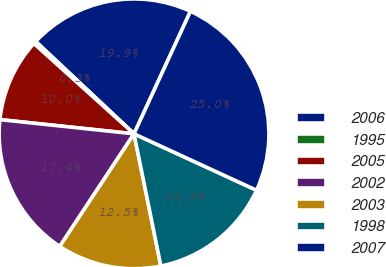Convert chart. <chart><loc_0><loc_0><loc_500><loc_500><pie_chart><fcel>2006<fcel>1995<fcel>2005<fcel>2002<fcel>2003<fcel>1998<fcel>2007<nl><fcel>19.87%<fcel>0.32%<fcel>10.0%<fcel>17.4%<fcel>12.47%<fcel>14.94%<fcel>25.0%<nl></chart> 